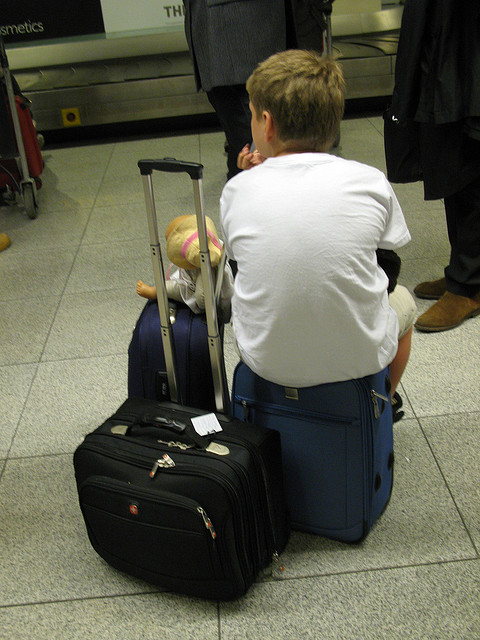Please identify all text content in this image. SMETICS TH 